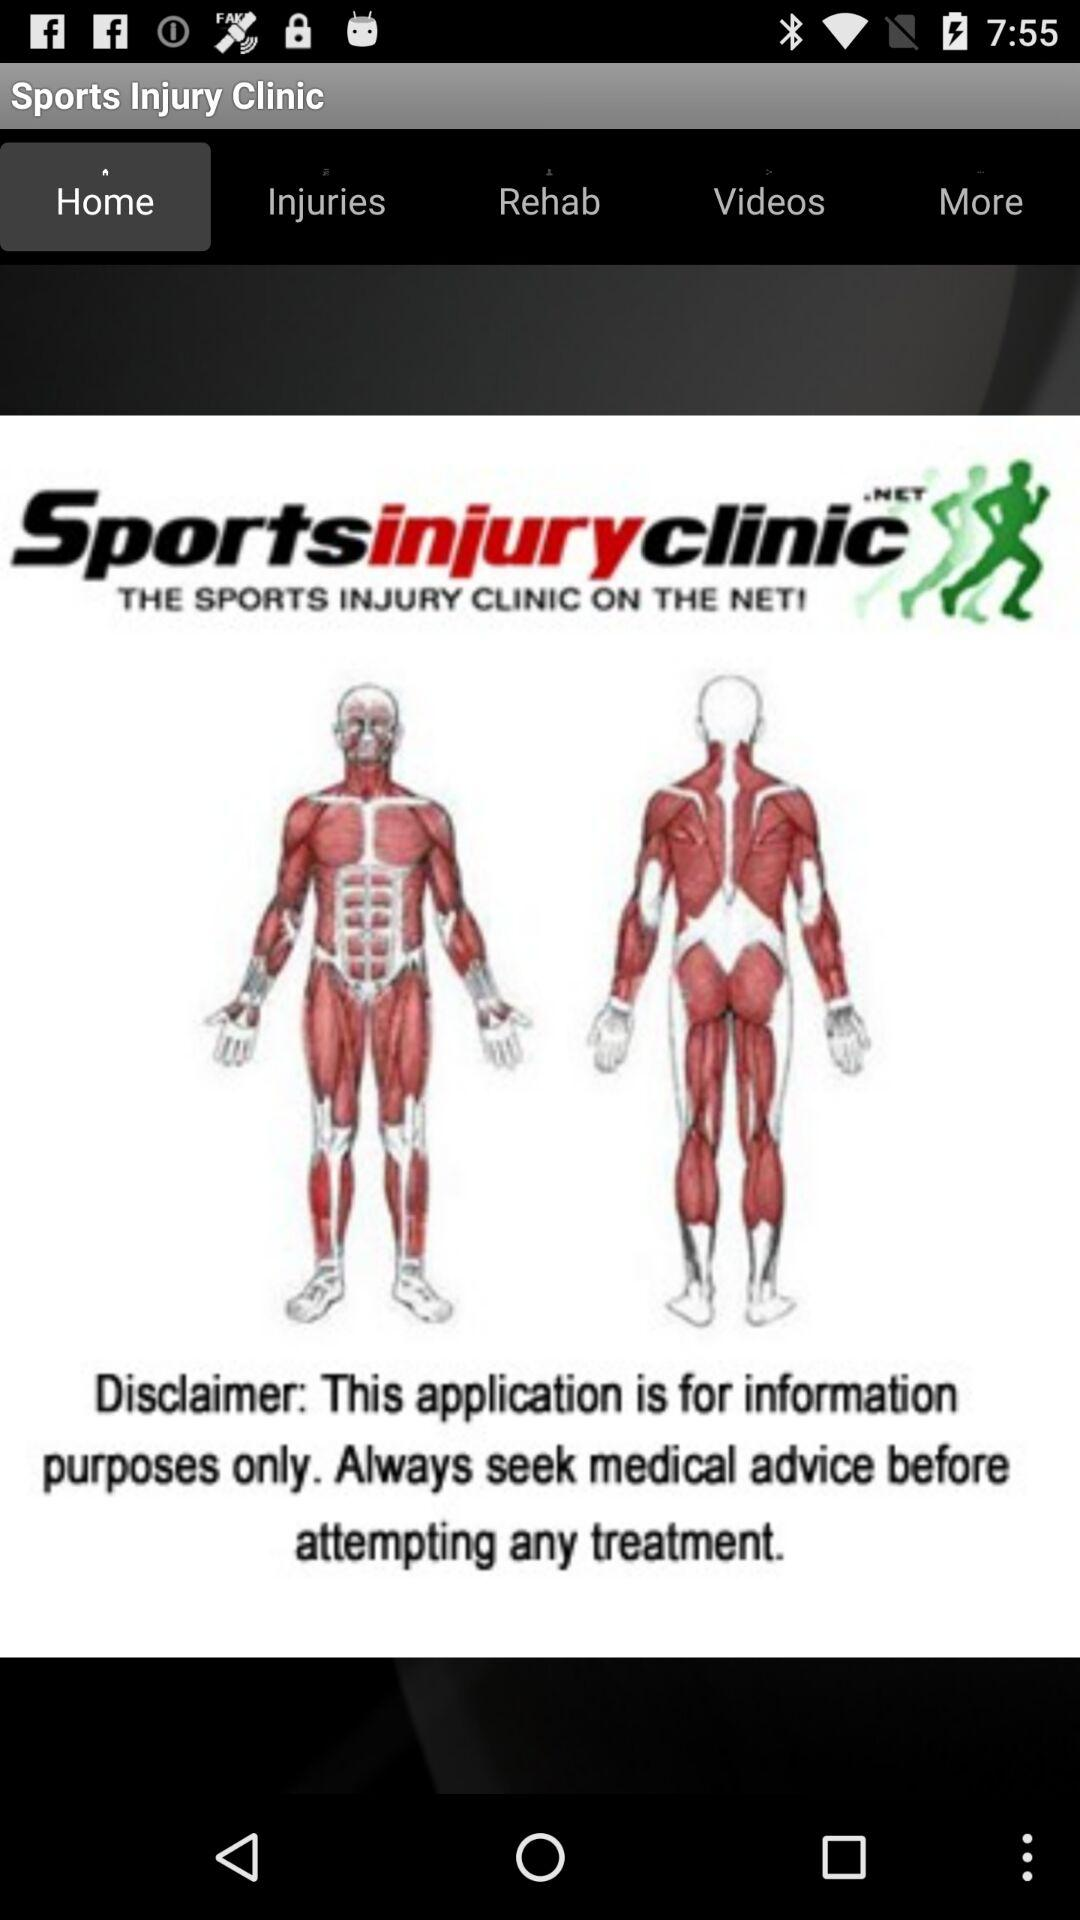Which tab is selected? The selected tab is "Home". 